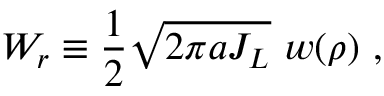<formula> <loc_0><loc_0><loc_500><loc_500>W _ { r } \equiv \frac { 1 } { 2 } \sqrt { 2 \pi a J _ { L } } \, w ( \rho ) \ ,</formula> 